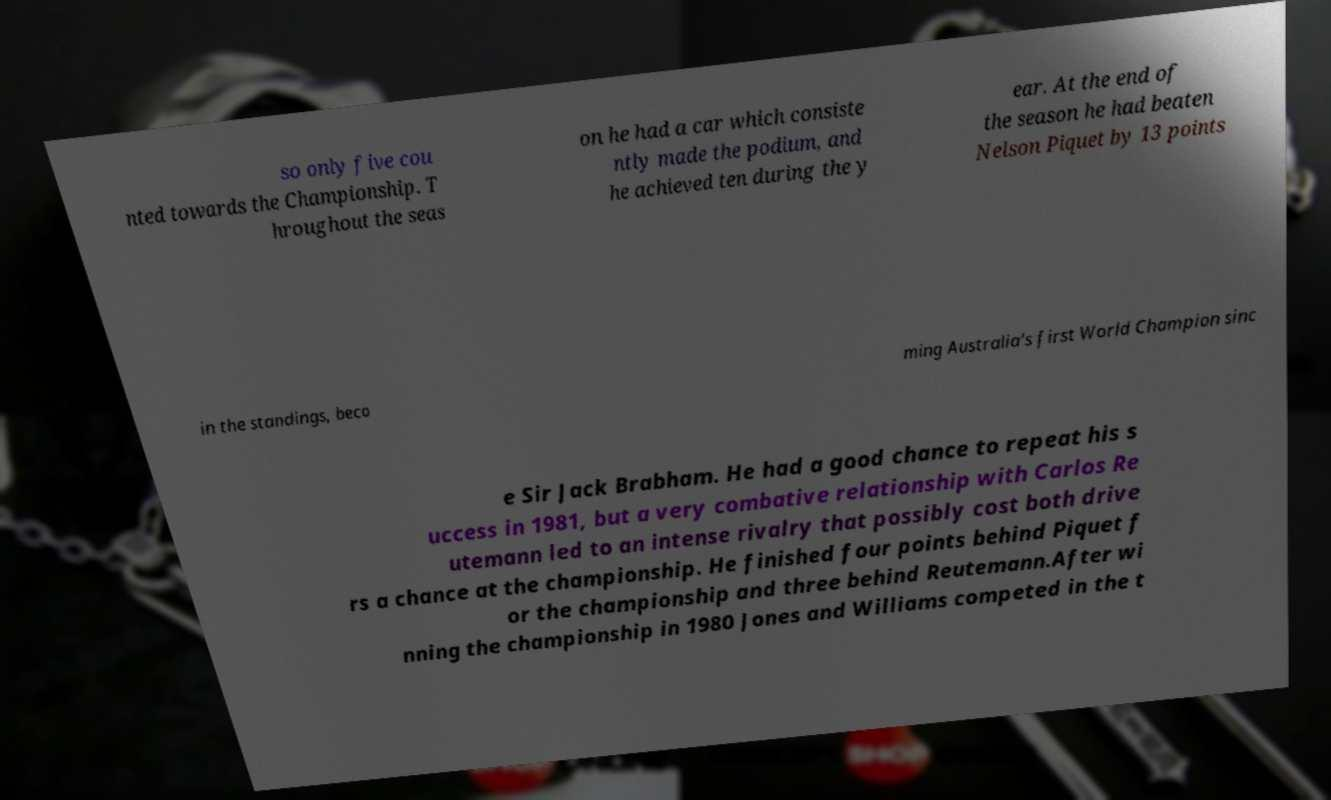For documentation purposes, I need the text within this image transcribed. Could you provide that? so only five cou nted towards the Championship. T hroughout the seas on he had a car which consiste ntly made the podium, and he achieved ten during the y ear. At the end of the season he had beaten Nelson Piquet by 13 points in the standings, beco ming Australia's first World Champion sinc e Sir Jack Brabham. He had a good chance to repeat his s uccess in 1981, but a very combative relationship with Carlos Re utemann led to an intense rivalry that possibly cost both drive rs a chance at the championship. He finished four points behind Piquet f or the championship and three behind Reutemann.After wi nning the championship in 1980 Jones and Williams competed in the t 